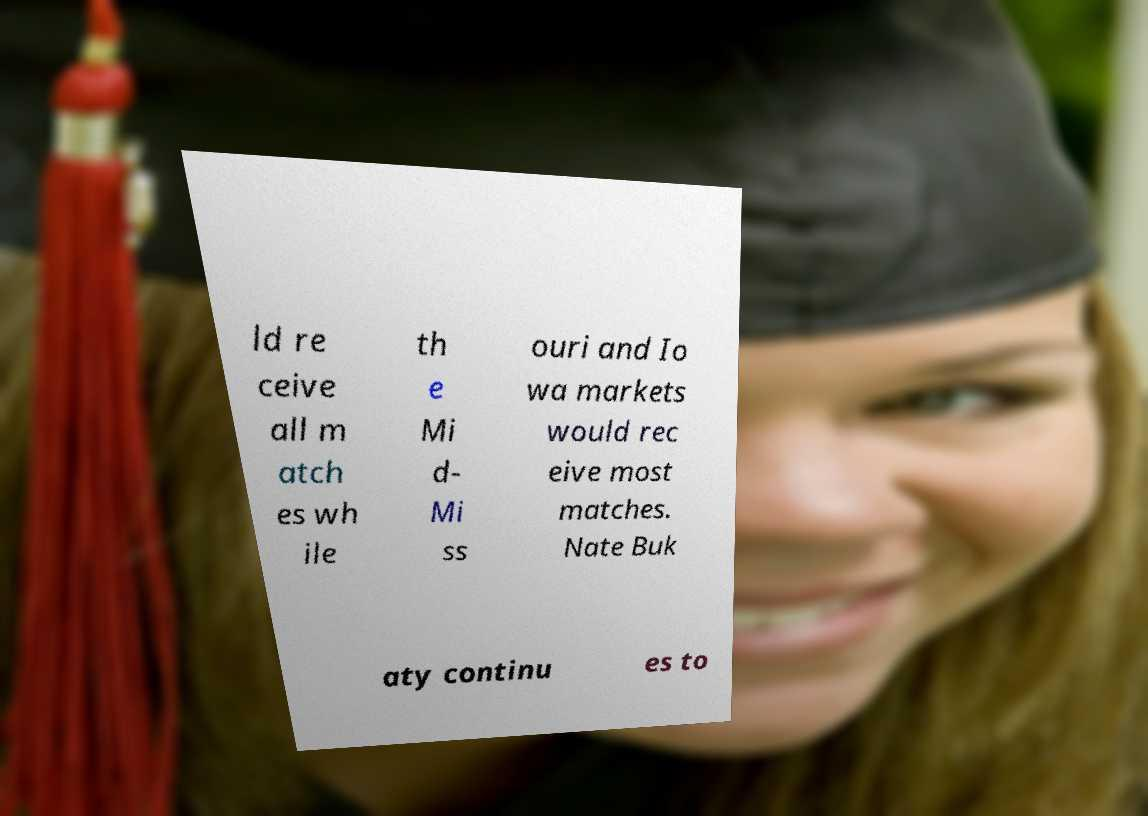Could you assist in decoding the text presented in this image and type it out clearly? ld re ceive all m atch es wh ile th e Mi d- Mi ss ouri and Io wa markets would rec eive most matches. Nate Buk aty continu es to 